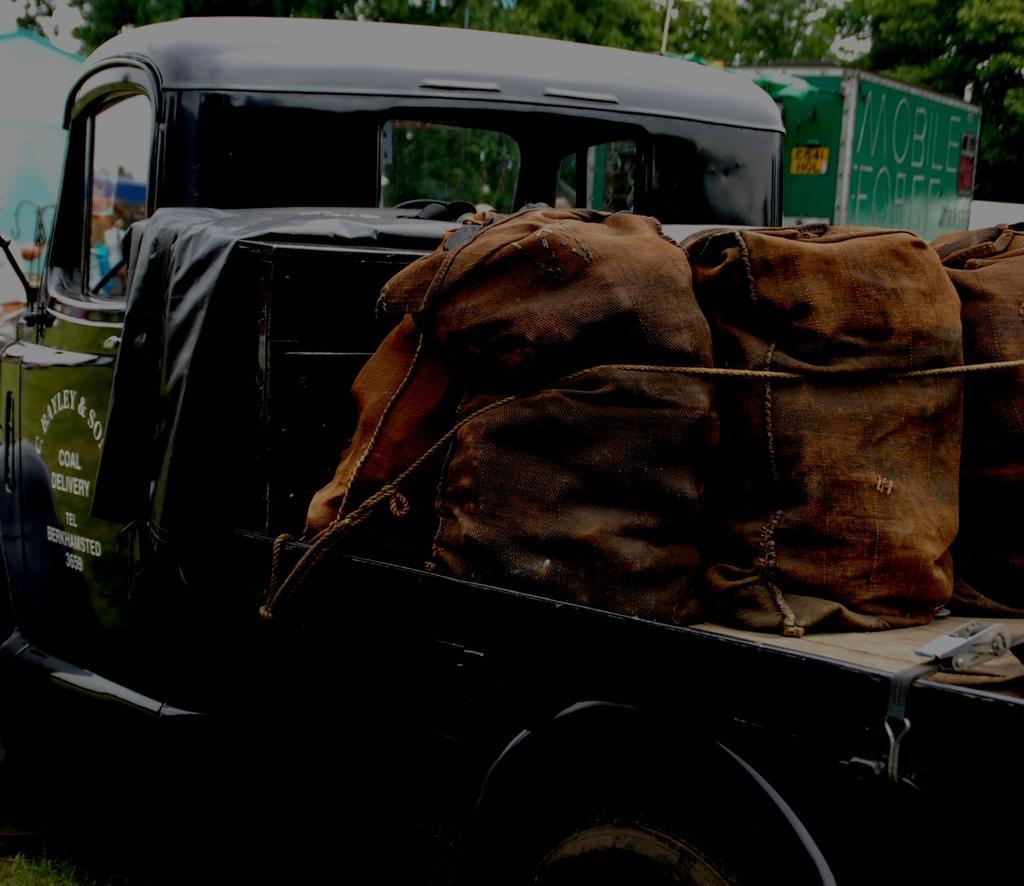Describe this image in one or two sentences. In the image there is a truck with bags and rope tied to it. In the background at the top of the image there are trees and also there is a green color board. 